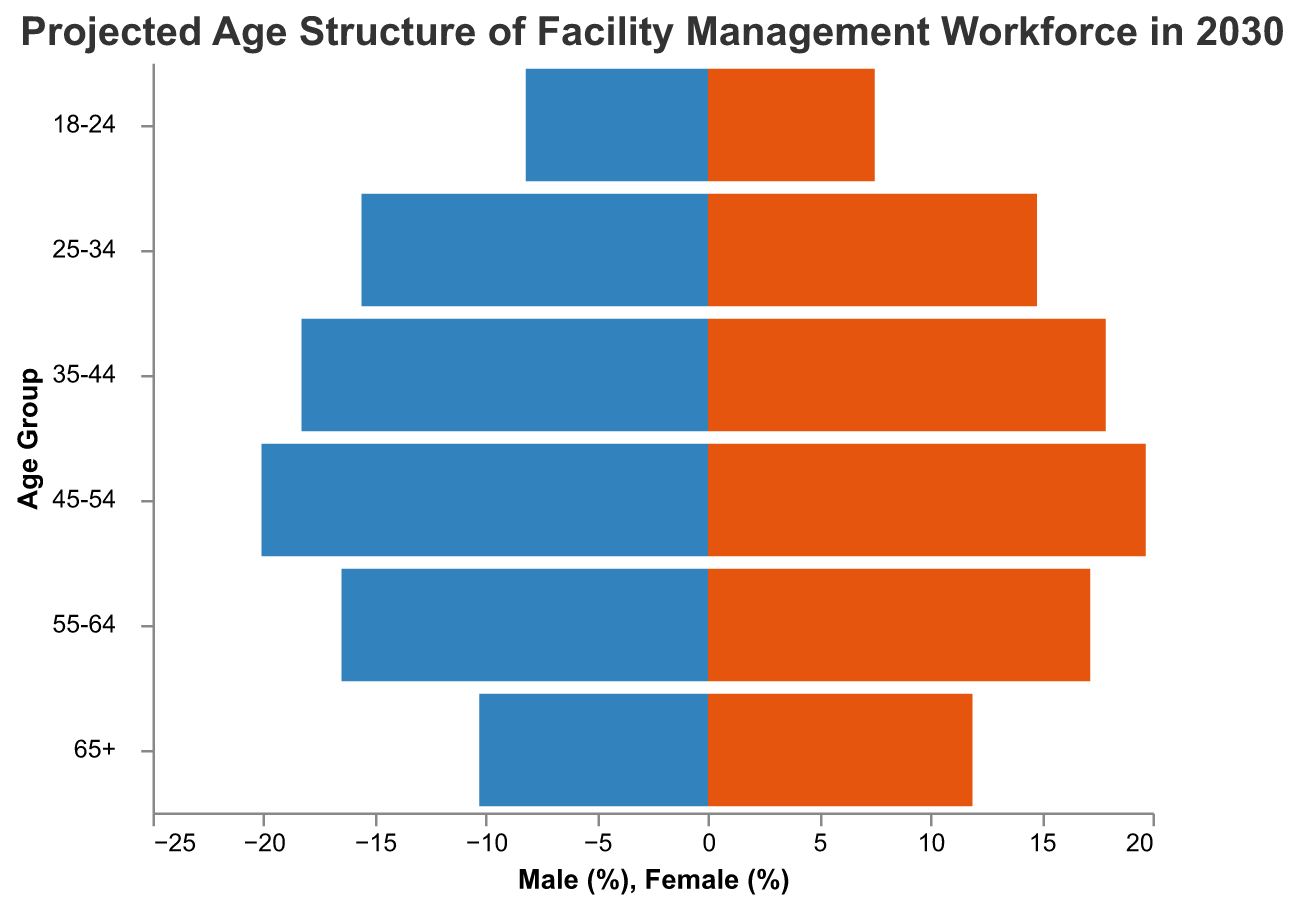What is the title of the figure? The title is the text displayed at the top of the figure. The title reads "Projected Age Structure of Facility Management Workforce in 2030".
Answer: Projected Age Structure of Facility Management Workforce in 2030 What age group has the largest male workforce? The male workforce is represented by the bars extending to the left. The age group with the largest bar extending to the left is 45-54.
Answer: 45-54 Which gender has a higher percentage in the 55-64 age group? The 55-64 age group shows two bars, one for male and one for female. Comparing the lengths of these bars, the female bar is slightly longer.
Answer: Female What is the difference in the percentage of females between the 18-24 and 65+ age groups? The percentage of females in the 18-24 age group is 7.5, and in the 65+ age group is 11.9. The difference is calculated as 11.9 - 7.5.
Answer: 4.4 In what age group are males and females the closest in percentage? We need to compare the percentage values for males and females across different age groups. The values for 35-44 are 18.3 (male) and 17.9 (female), with a difference of 0.4, which is the smallest difference among the groups.
Answer: 35-44 Rank the age groups from highest to lowest percentage for males. The percentage values for males in descending order are 45-54 (20.1), 35-44 (18.3), 55-64 (16.5), 25-34 (15.6), 65+ (10.3), and 18-24 (8.2).
Answer: 45-54, 35-44, 55-64, 25-34, 65+, 18-24 What is the combined percentage of males and females in the 25-34 age group? The male percentage for the 25-34 age group is 15.6, and the female percentage is 14.8. The combined percentage is 15.6 + 14.8.
Answer: 30.4 Which age group has the smallest combined workforce percentage? The combined percentage can be calculated for each age group. For the 18-24 age group, it is 8.2 + 7.5 = 15.7, which is the smallest among all age groups.
Answer: 18-24 Is the trend of workforce percentage increasing or decreasing with age for females? Looking at the female percentages from the youngest to the oldest age group: 7.5, 14.8, 17.9, 19.7, 17.2, and 11.9. The data shows an increase up to 45-54 followed by a decrease.
Answer: Increase then Decrease 